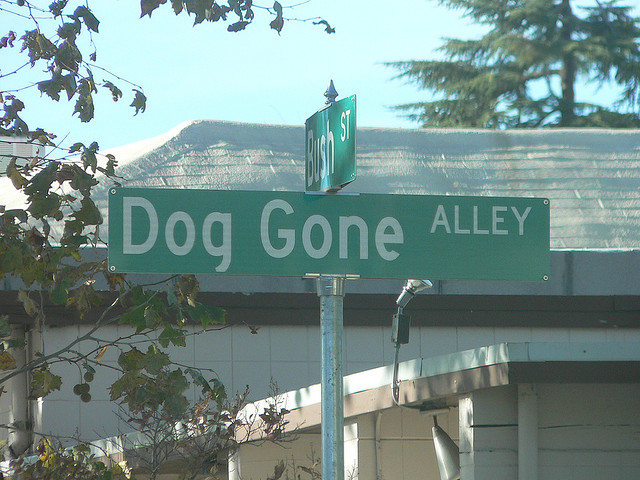Please extract the text content from this image. Bush ST Dog Gone ALLEY 